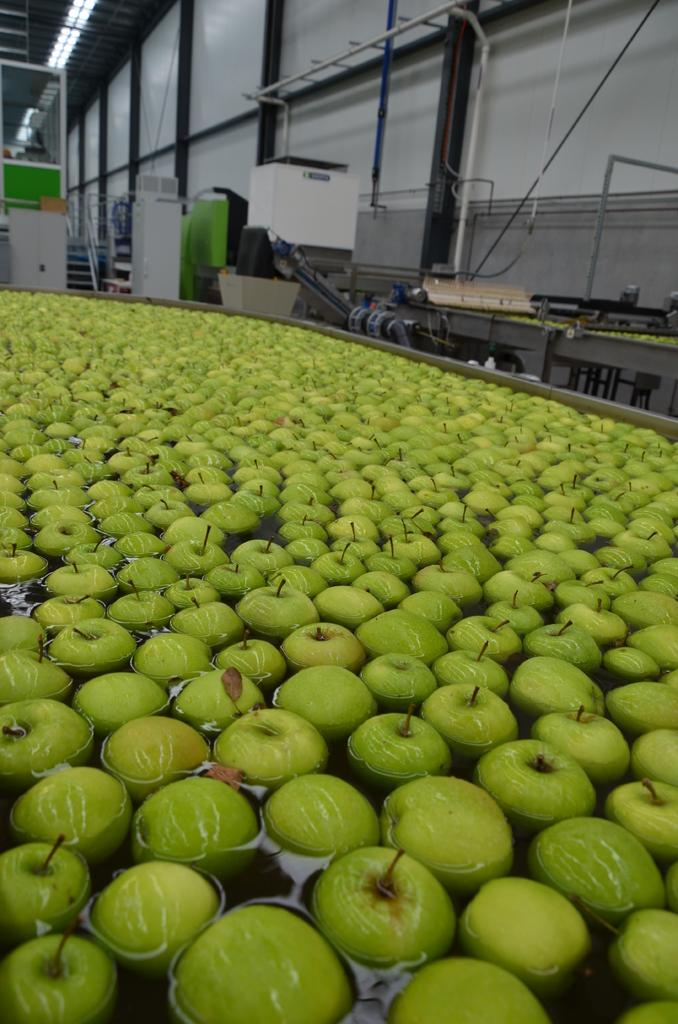What is the primary element in the image? There is water in the image. What can be seen floating in the water? There are green color fruits in the water. What can be seen in the background of the image? There are equipment visible in the background of the image, as well as other unspecified things. How many lizards can be seen climbing on the foot in the image? There are no lizards or feet present in the image. What story is being told in the image? The image does not depict a story; it is a simple representation of water with green color fruits floating in it and equipment visible in the background. 